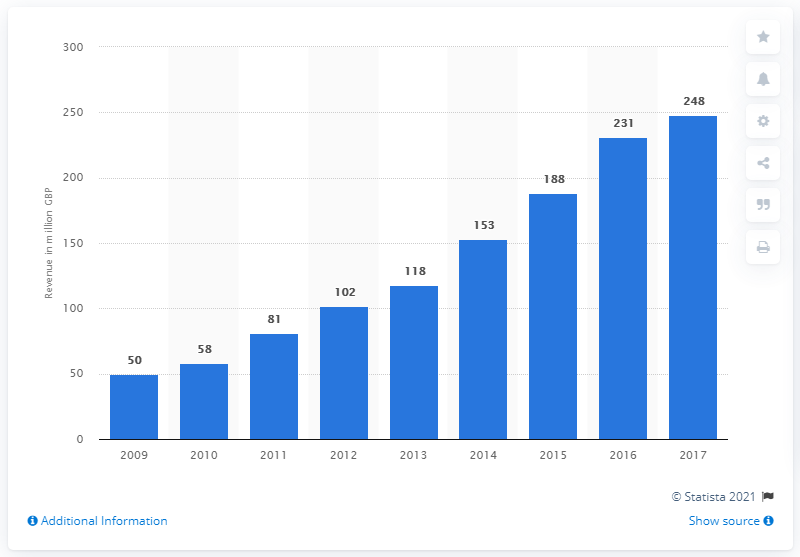Point out several critical features in this image. ITV's online, pay, and interactive revenue in 2017 was 248 million pounds. 